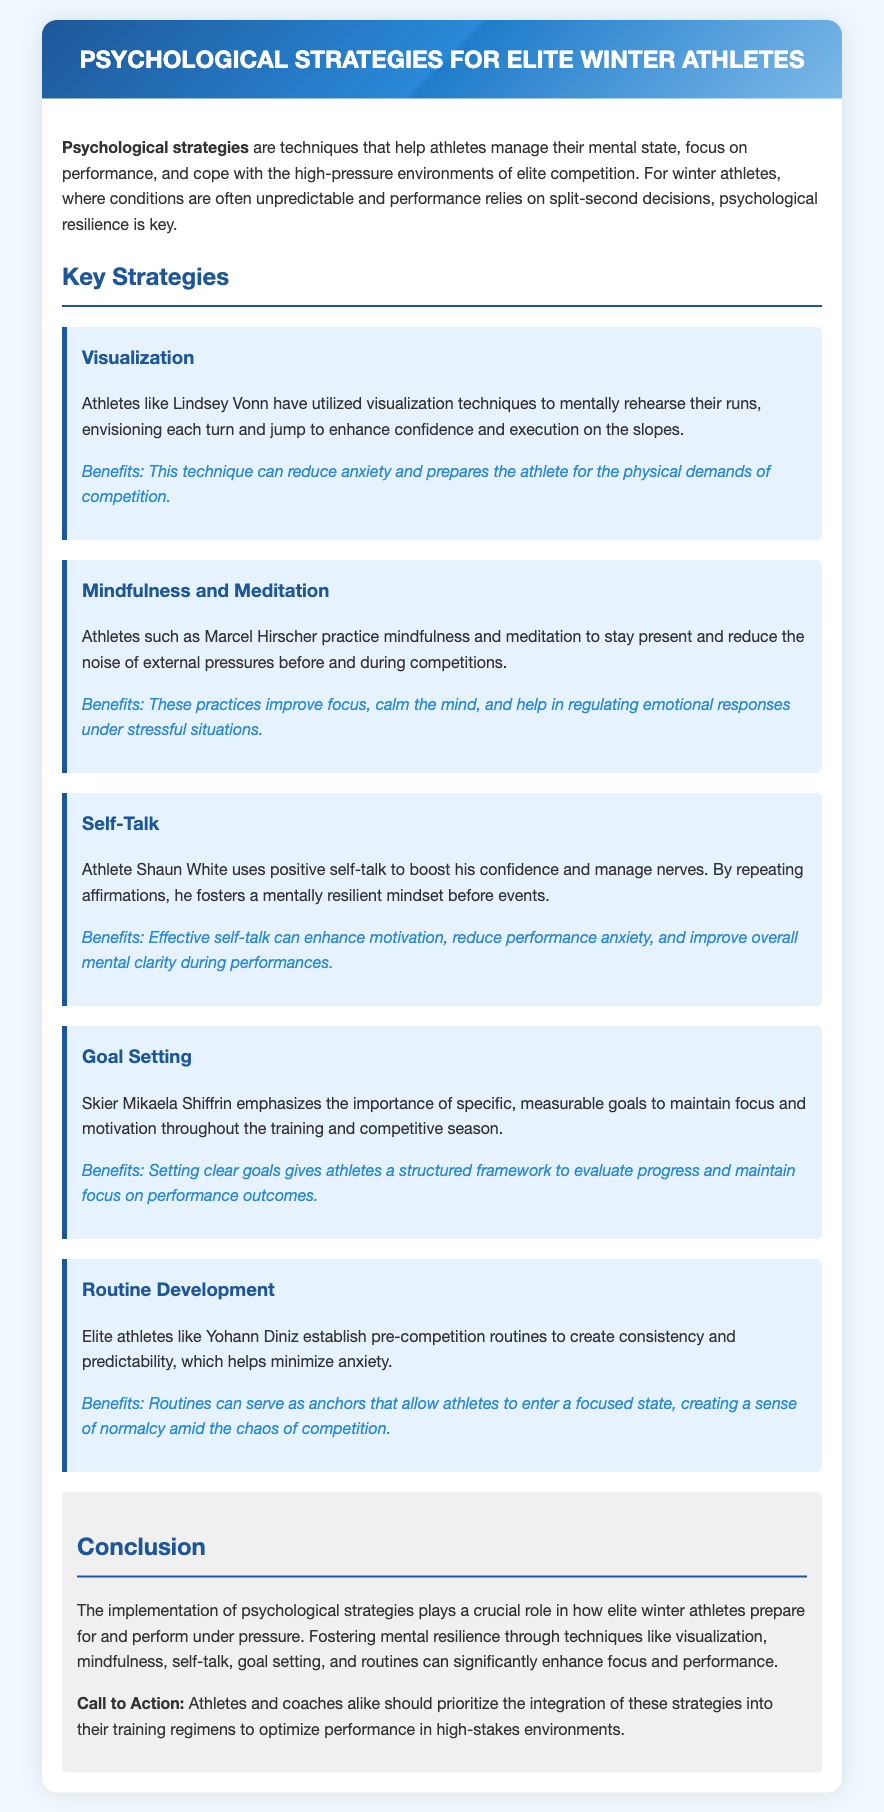What psychological strategy is emphasized by Mikaela Shiffrin? Mikaela Shiffrin emphasizes the importance of specific, measurable goals as a psychological strategy.
Answer: Goal Setting Who utilized visualization techniques for their runs? Lindsey Vonn is noted for utilizing visualization techniques to enhance confidence and execution on the slopes.
Answer: Lindsey Vonn What does mindfulness and meditation help athletes do? Mindfulness and meditation help athletes stay present and reduce external pressures.
Answer: Improve focus Name one benefit of self-talk mentioned in the document. One benefit of self-talk is that it can enhance motivation and reduce performance anxiety.
Answer: Enhance motivation What is a psychological strategy that Yohann Diniz uses before competitions? Yohann Diniz establishes pre-competition routines to create consistency and predictability.
Answer: Routine Development How does visualization technique affect an athlete's anxiety? Visualization techniques can reduce anxiety and prepare athletes for competition.
Answer: Reduce anxiety What type of document is this? This document is a note discussing psychological strategies for elite winter athletes.
Answer: Note 